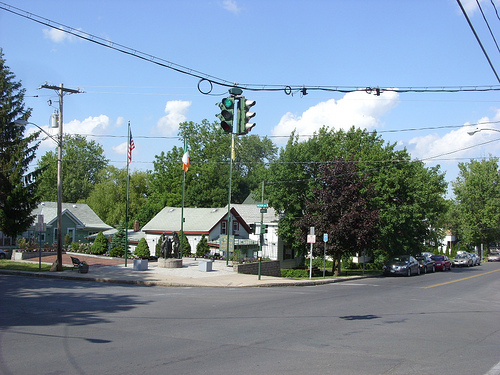What time of year does it appear to be in the image? The lush greenery of the trees and the bright sunlight suggest that it is late spring or summer. The absence of leaves on the ground and the thriving foliage indicate a time of year when plants are in full bloom. 